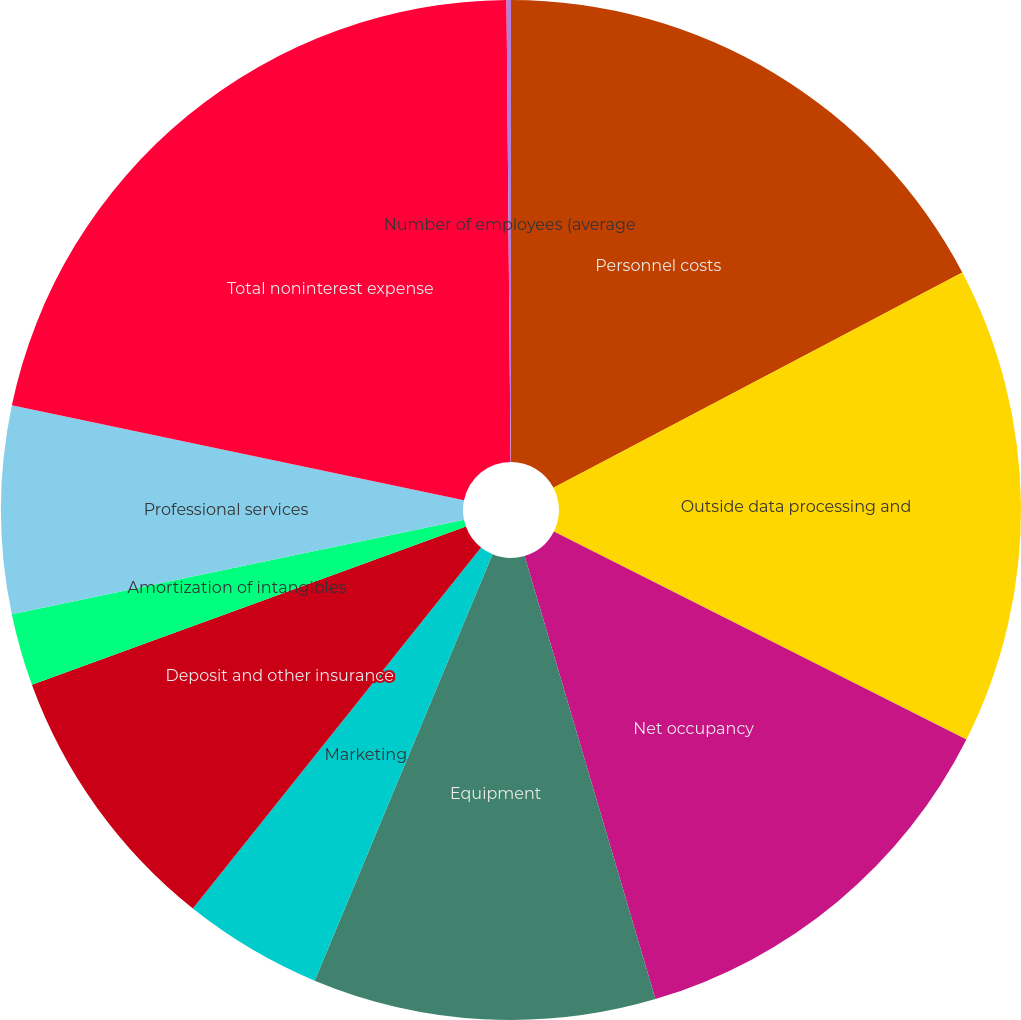Convert chart. <chart><loc_0><loc_0><loc_500><loc_500><pie_chart><fcel>Personnel costs<fcel>Outside data processing and<fcel>Net occupancy<fcel>Equipment<fcel>Marketing<fcel>Deposit and other insurance<fcel>Amortization of intangibles<fcel>Professional services<fcel>Total noninterest expense<fcel>Number of employees (average<nl><fcel>17.29%<fcel>15.14%<fcel>13.0%<fcel>10.86%<fcel>4.43%<fcel>8.71%<fcel>2.29%<fcel>6.57%<fcel>21.57%<fcel>0.14%<nl></chart> 